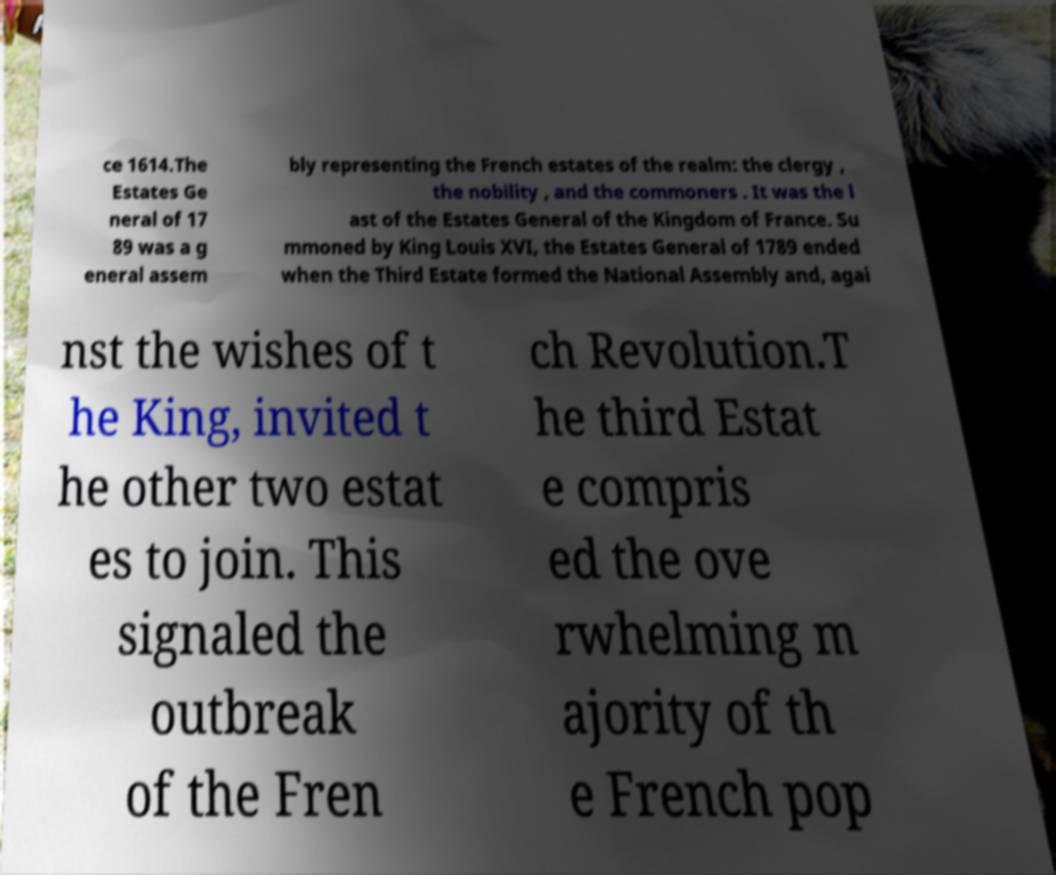There's text embedded in this image that I need extracted. Can you transcribe it verbatim? ce 1614.The Estates Ge neral of 17 89 was a g eneral assem bly representing the French estates of the realm: the clergy , the nobility , and the commoners . It was the l ast of the Estates General of the Kingdom of France. Su mmoned by King Louis XVI, the Estates General of 1789 ended when the Third Estate formed the National Assembly and, agai nst the wishes of t he King, invited t he other two estat es to join. This signaled the outbreak of the Fren ch Revolution.T he third Estat e compris ed the ove rwhelming m ajority of th e French pop 